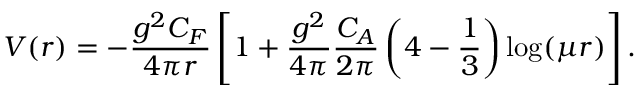Convert formula to latex. <formula><loc_0><loc_0><loc_500><loc_500>{ V ( r ) = - \frac { g ^ { 2 } C _ { F } } { 4 \pi r } \left [ 1 + \frac { g ^ { 2 } } { 4 \pi } \frac { C _ { A } } { 2 \pi } \left ( { 4 } - \frac { 1 } { 3 } \right ) \log ( \mu r ) \right ] } \, .</formula> 